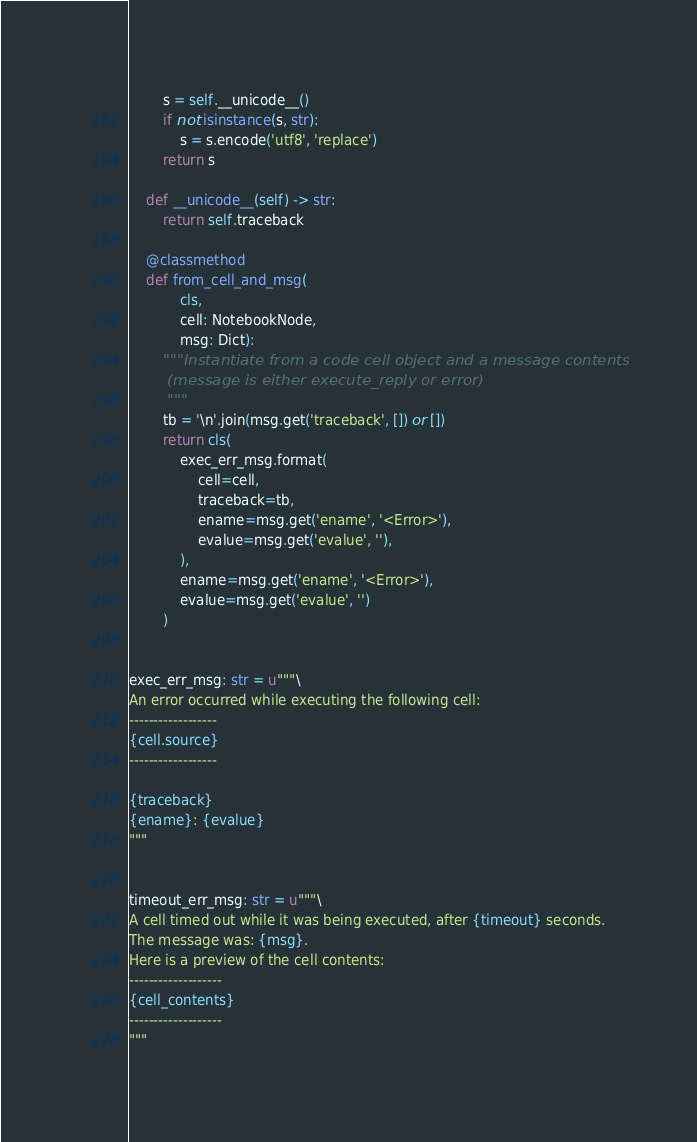<code> <loc_0><loc_0><loc_500><loc_500><_Python_>        s = self.__unicode__()
        if not isinstance(s, str):
            s = s.encode('utf8', 'replace')
        return s

    def __unicode__(self) -> str:
        return self.traceback

    @classmethod
    def from_cell_and_msg(
            cls,
            cell: NotebookNode,
            msg: Dict):
        """Instantiate from a code cell object and a message contents
        (message is either execute_reply or error)
        """
        tb = '\n'.join(msg.get('traceback', []) or [])
        return cls(
            exec_err_msg.format(
                cell=cell,
                traceback=tb,
                ename=msg.get('ename', '<Error>'),
                evalue=msg.get('evalue', ''),
            ),
            ename=msg.get('ename', '<Error>'),
            evalue=msg.get('evalue', '')
        )


exec_err_msg: str = u"""\
An error occurred while executing the following cell:
------------------
{cell.source}
------------------

{traceback}
{ename}: {evalue}
"""


timeout_err_msg: str = u"""\
A cell timed out while it was being executed, after {timeout} seconds.
The message was: {msg}.
Here is a preview of the cell contents:
-------------------
{cell_contents}
-------------------
"""
</code> 